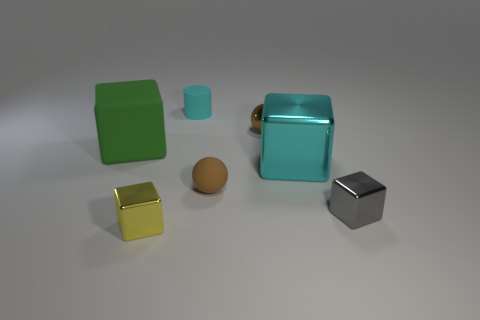Is the color of the tiny metallic ball the same as the small rubber sphere?
Provide a short and direct response. Yes. Is there any other thing that has the same shape as the small cyan object?
Provide a short and direct response. No. What number of other tiny cylinders have the same color as the matte cylinder?
Your answer should be very brief. 0. What color is the small sphere that is to the left of the tiny ball behind the large object on the left side of the tiny yellow shiny block?
Keep it short and to the point. Brown. Is the material of the large cyan object the same as the small gray cube?
Your answer should be very brief. Yes. Do the green matte thing and the small brown rubber object have the same shape?
Keep it short and to the point. No. Is the number of yellow things behind the tiny metallic sphere the same as the number of metallic objects to the right of the yellow object?
Give a very brief answer. No. What is the color of the big cube that is the same material as the cylinder?
Ensure brevity in your answer.  Green. How many blue things have the same material as the cyan cylinder?
Offer a terse response. 0. There is a large block that is to the right of the small yellow metallic block; is it the same color as the small cylinder?
Your answer should be very brief. Yes. 